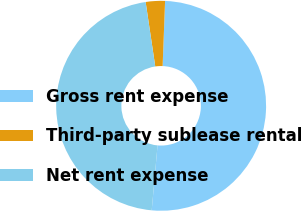Convert chart. <chart><loc_0><loc_0><loc_500><loc_500><pie_chart><fcel>Gross rent expense<fcel>Third-party sublease rental<fcel>Net rent expense<nl><fcel>50.83%<fcel>2.96%<fcel>46.21%<nl></chart> 